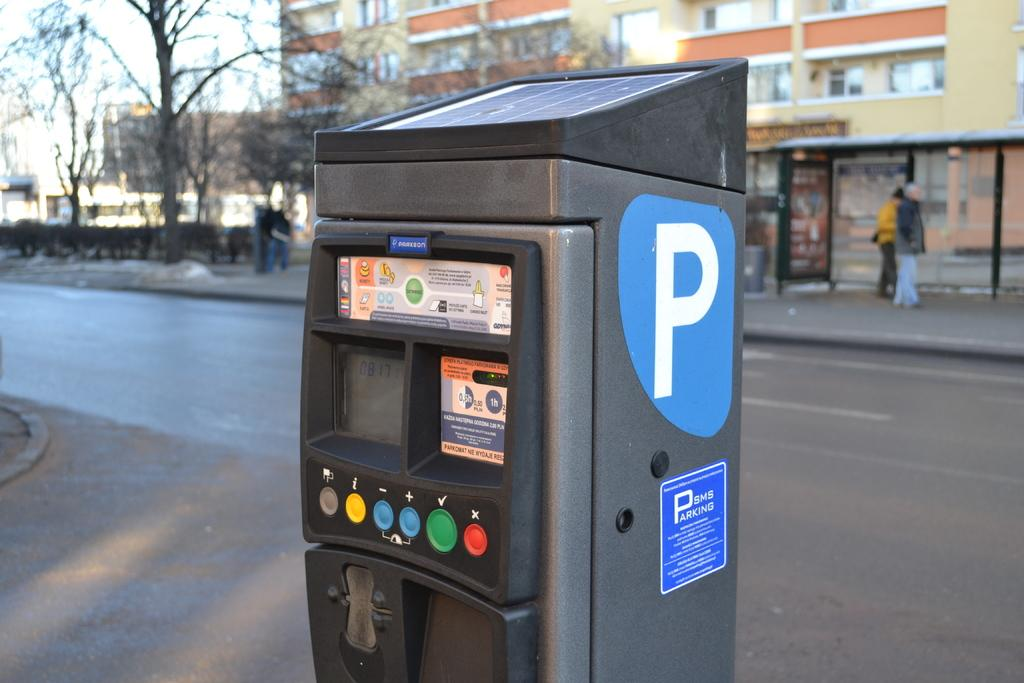Provide a one-sentence caption for the provided image. A black machine on the street has a large P on it. 